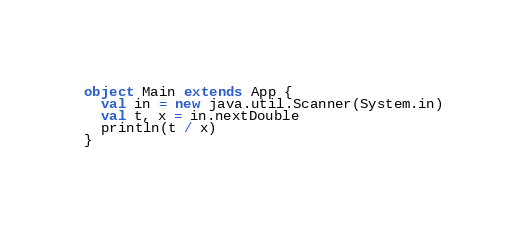Convert code to text. <code><loc_0><loc_0><loc_500><loc_500><_Scala_>object Main extends App {
  val in = new java.util.Scanner(System.in)
  val t, x = in.nextDouble
  println(t / x)
}</code> 